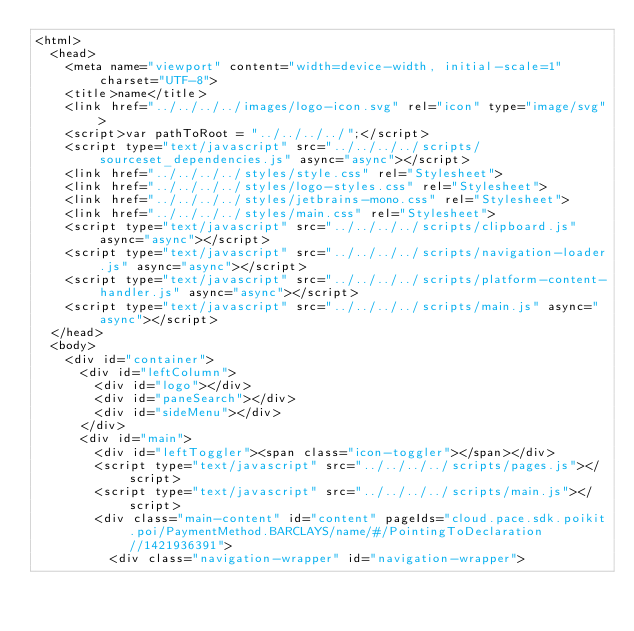<code> <loc_0><loc_0><loc_500><loc_500><_HTML_><html>
  <head>
    <meta name="viewport" content="width=device-width, initial-scale=1" charset="UTF-8">
    <title>name</title>
    <link href="../../../../images/logo-icon.svg" rel="icon" type="image/svg">
    <script>var pathToRoot = "../../../../";</script>
    <script type="text/javascript" src="../../../../scripts/sourceset_dependencies.js" async="async"></script>
    <link href="../../../../styles/style.css" rel="Stylesheet">
    <link href="../../../../styles/logo-styles.css" rel="Stylesheet">
    <link href="../../../../styles/jetbrains-mono.css" rel="Stylesheet">
    <link href="../../../../styles/main.css" rel="Stylesheet">
    <script type="text/javascript" src="../../../../scripts/clipboard.js" async="async"></script>
    <script type="text/javascript" src="../../../../scripts/navigation-loader.js" async="async"></script>
    <script type="text/javascript" src="../../../../scripts/platform-content-handler.js" async="async"></script>
    <script type="text/javascript" src="../../../../scripts/main.js" async="async"></script>
  </head>
  <body>
    <div id="container">
      <div id="leftColumn">
        <div id="logo"></div>
        <div id="paneSearch"></div>
        <div id="sideMenu"></div>
      </div>
      <div id="main">
        <div id="leftToggler"><span class="icon-toggler"></span></div>
        <script type="text/javascript" src="../../../../scripts/pages.js"></script>
        <script type="text/javascript" src="../../../../scripts/main.js"></script>
        <div class="main-content" id="content" pageIds="cloud.pace.sdk.poikit.poi/PaymentMethod.BARCLAYS/name/#/PointingToDeclaration//1421936391">
          <div class="navigation-wrapper" id="navigation-wrapper"></code> 